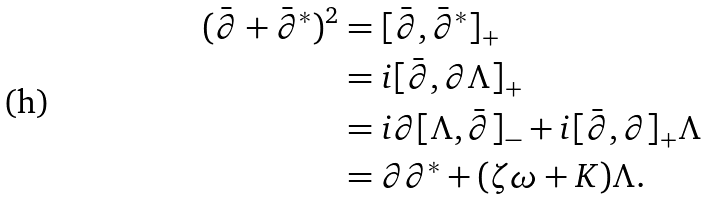Convert formula to latex. <formula><loc_0><loc_0><loc_500><loc_500>( \bar { \partial } + { \bar { \partial } } ^ { * } ) ^ { 2 } & = [ \bar { \partial } , { \bar { \partial } } ^ { * } ] _ { + } \\ & = i [ \bar { \partial } , \partial \Lambda ] _ { + } \\ & = i \partial [ \Lambda , \bar { \partial } ] _ { - } + i [ \bar { \partial } , \partial ] _ { + } \Lambda \\ & = \partial \partial ^ { * } + ( \zeta \omega + K ) \Lambda \mbox .</formula> 